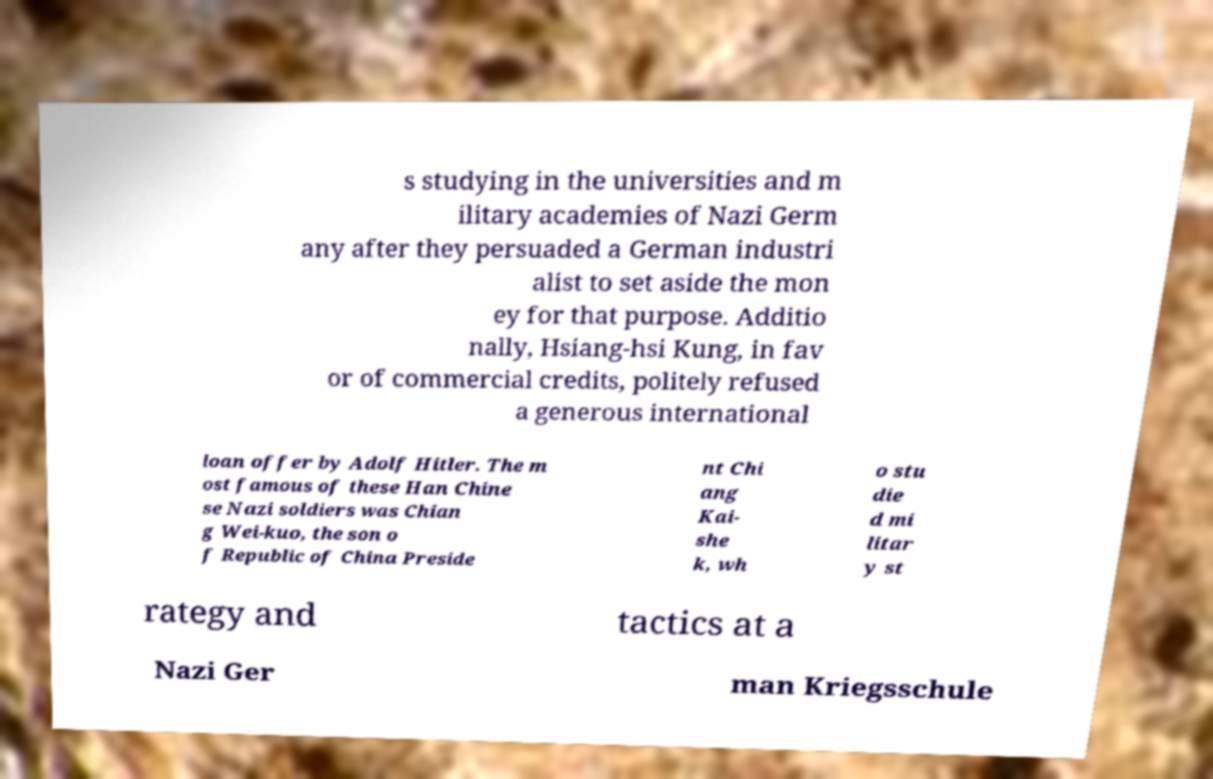Could you assist in decoding the text presented in this image and type it out clearly? s studying in the universities and m ilitary academies of Nazi Germ any after they persuaded a German industri alist to set aside the mon ey for that purpose. Additio nally, Hsiang-hsi Kung, in fav or of commercial credits, politely refused a generous international loan offer by Adolf Hitler. The m ost famous of these Han Chine se Nazi soldiers was Chian g Wei-kuo, the son o f Republic of China Preside nt Chi ang Kai- she k, wh o stu die d mi litar y st rategy and tactics at a Nazi Ger man Kriegsschule 